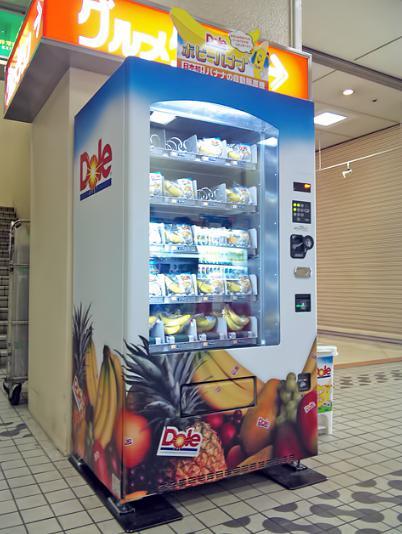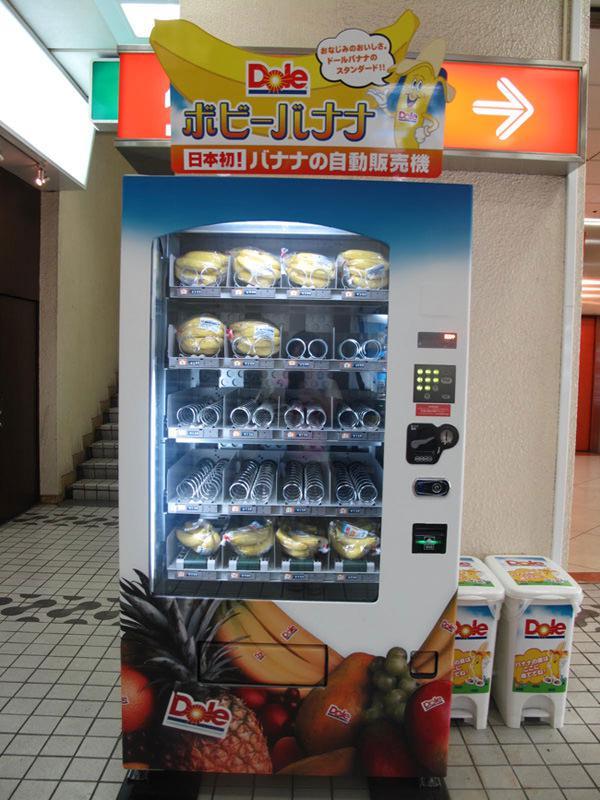The first image is the image on the left, the second image is the image on the right. Given the left and right images, does the statement "The right image shows a row of at least four vending machines." hold true? Answer yes or no. No. 